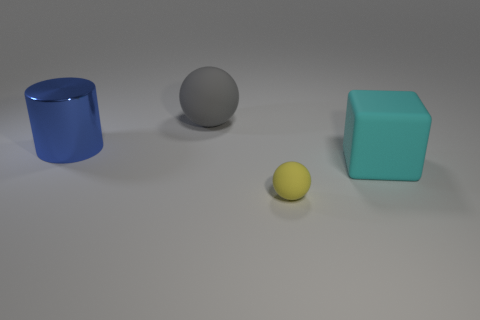What number of other things are there of the same shape as the gray rubber object? There is one other object that shares the same spherical shape as the gray rubber ball: the small yellow ball. 